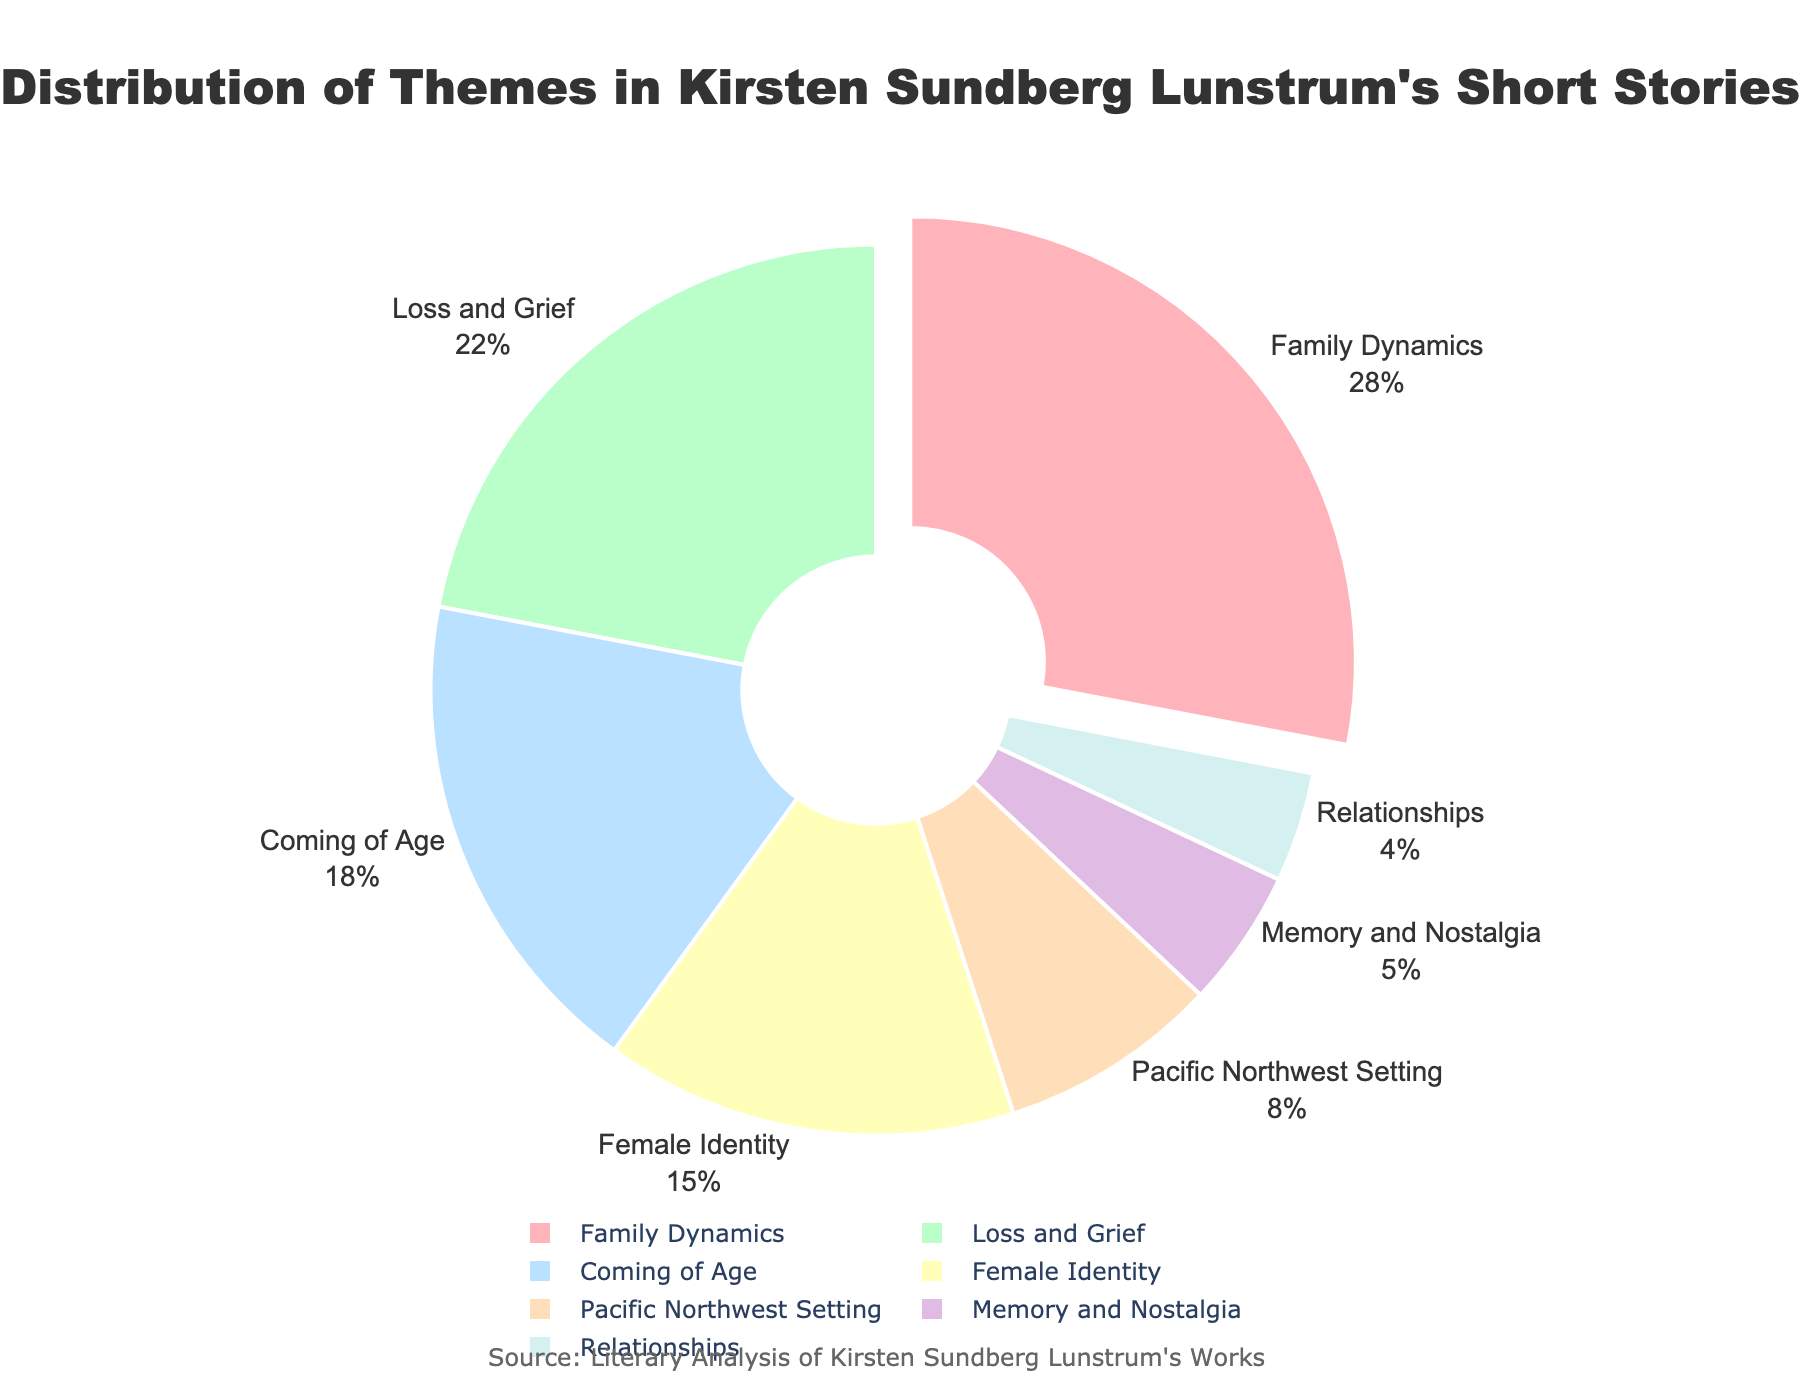What percentage of the themes is related to personal growth, if we combine 'Coming of Age' and 'Female Identity'? Adding the percentages for 'Coming of Age' (18%) and 'Female Identity' (15%) gives 18% + 15% = 33%.
Answer: 33% What is the difference in percentage between 'Family Dynamics' and 'Loss and Grief'? Subtracting the percentage for 'Loss and Grief' (22%) from 'Family Dynamics' (28%) gives 28% - 22% = 6%.
Answer: 6% Which theme has the smallest representation in the pie chart, and what is its percentage? By observing the segments of the pie chart, 'Relationships' has the smallest representation with a percentage of 4%.
Answer: Relationships, 4% If you combine the percentages of 'Family Dynamics', 'Loss and Grief', and 'Coming of Age', what is the total? Summing the percentages for 'Family Dynamics' (28%), 'Loss and Grief' (22%), and 'Coming of Age' (18%) gives 28% + 22% + 18% = 68%.
Answer: 68% Among 'Memory and Nostalgia' and 'Pacific Northwest Setting', which theme has a higher percentage representation, and by how much? Comparing the percentages, 'Pacific Northwest Setting' (8%) is higher than 'Memory and Nostalgia' (5%) by 3% (8% - 5% = 3%).
Answer: Pacific Northwest Setting, 3% Which theme's percentage gets pulled out from the pie chart, and what is its value? In the pie chart, the slice for 'Family Dynamics' is pulled out, and its percentage is 28%.
Answer: Family Dynamics, 28% What is the combined percentage of the themes 'Memory and Nostalgia' and 'Relationships'? Adding the percentages for 'Memory and Nostalgia' (5%) and 'Relationships' (4%) gives 5% + 4% = 9%.
Answer: 9% How many themes together make up more than half of the pie chart? Adding the percentages: 'Family Dynamics' (28%), 'Loss and Grief' (22%), and 'Coming of Age' (18%) give a combined percentage of 28% + 22% + 18% = 68%, which is more than half. Hence, 3 themes.
Answer: 3 Is the percentage of 'Female Identity' greater than 'Pacific Northwest Setting' and 'Memory and Nostalgia' combined? Summing the percentages for 'Pacific Northwest Setting' (8%) and 'Memory and Nostalgia' (5%) gives 8% + 5% = 13%. Since 'Female Identity' is 15%, it is indeed greater.
Answer: Yes What is the percentage sum of the least two represented themes? Adding the percentages for 'Memory and Nostalgia' (5%) and 'Relationships' (4%) gives 5% + 4% = 9%.
Answer: 9% 